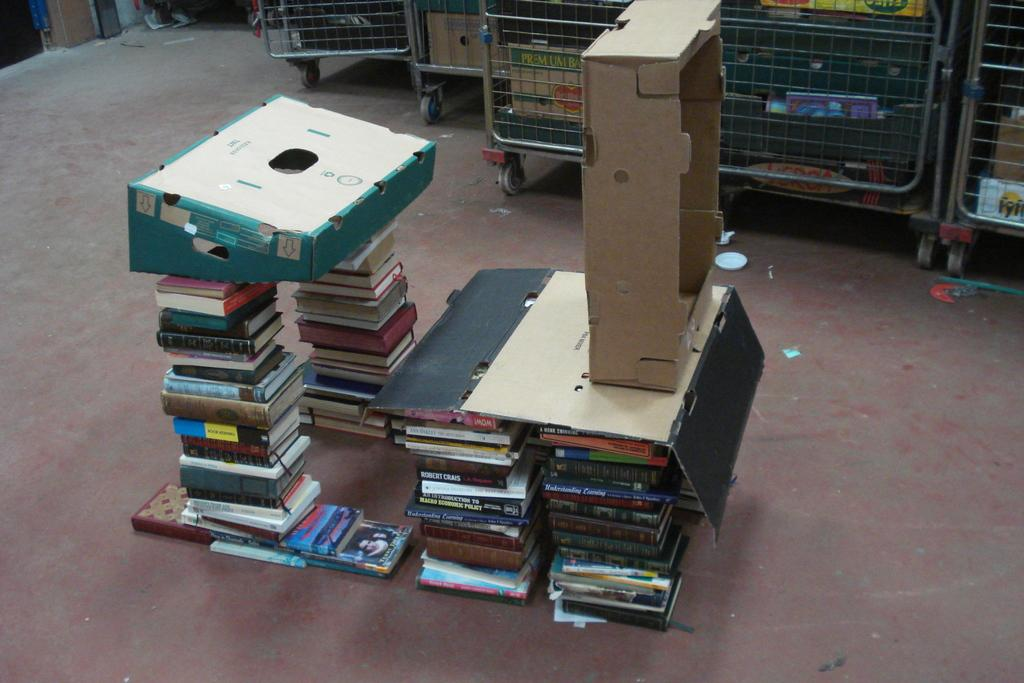What is the main subject in the center of the image? There are books in the center of the image. What can be seen on the floor in the image? There are boxes on the floor. What is located at the top of the image? There are trolleys at the top of the image. What is inside the trolleys? There are boxes and other objects in the trolleys. What type of bead is used to decorate the books in the image? There are no beads present in the image, and the books are not decorated with any beads. What time is displayed on the watch in the image? There is no watch present in the image. 